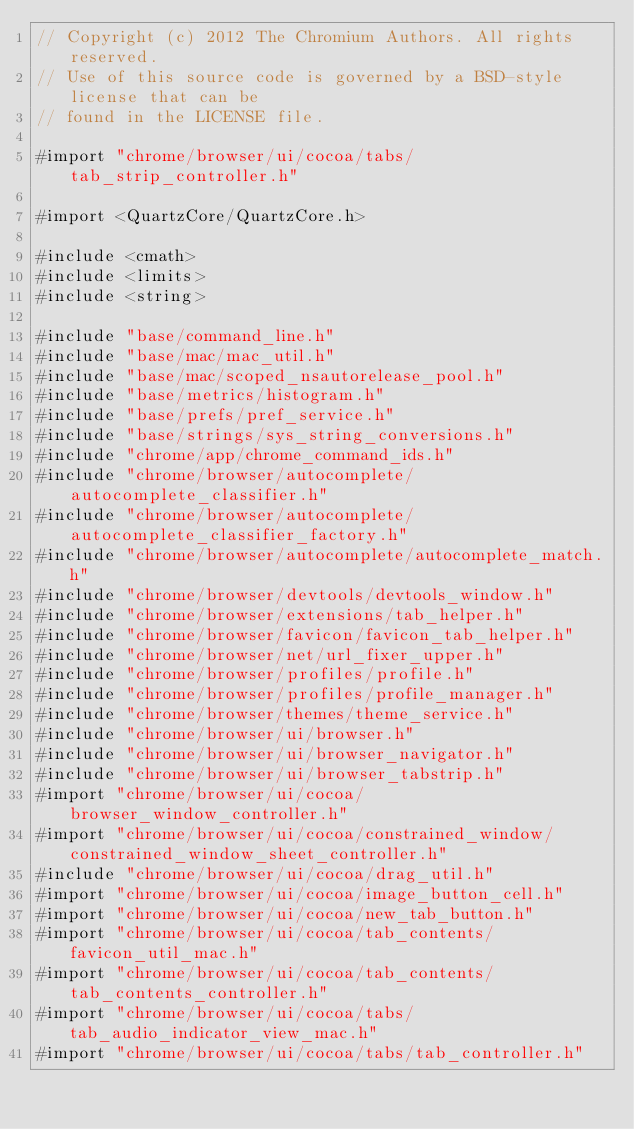Convert code to text. <code><loc_0><loc_0><loc_500><loc_500><_ObjectiveC_>// Copyright (c) 2012 The Chromium Authors. All rights reserved.
// Use of this source code is governed by a BSD-style license that can be
// found in the LICENSE file.

#import "chrome/browser/ui/cocoa/tabs/tab_strip_controller.h"

#import <QuartzCore/QuartzCore.h>

#include <cmath>
#include <limits>
#include <string>

#include "base/command_line.h"
#include "base/mac/mac_util.h"
#include "base/mac/scoped_nsautorelease_pool.h"
#include "base/metrics/histogram.h"
#include "base/prefs/pref_service.h"
#include "base/strings/sys_string_conversions.h"
#include "chrome/app/chrome_command_ids.h"
#include "chrome/browser/autocomplete/autocomplete_classifier.h"
#include "chrome/browser/autocomplete/autocomplete_classifier_factory.h"
#include "chrome/browser/autocomplete/autocomplete_match.h"
#include "chrome/browser/devtools/devtools_window.h"
#include "chrome/browser/extensions/tab_helper.h"
#include "chrome/browser/favicon/favicon_tab_helper.h"
#include "chrome/browser/net/url_fixer_upper.h"
#include "chrome/browser/profiles/profile.h"
#include "chrome/browser/profiles/profile_manager.h"
#include "chrome/browser/themes/theme_service.h"
#include "chrome/browser/ui/browser.h"
#include "chrome/browser/ui/browser_navigator.h"
#include "chrome/browser/ui/browser_tabstrip.h"
#import "chrome/browser/ui/cocoa/browser_window_controller.h"
#import "chrome/browser/ui/cocoa/constrained_window/constrained_window_sheet_controller.h"
#include "chrome/browser/ui/cocoa/drag_util.h"
#import "chrome/browser/ui/cocoa/image_button_cell.h"
#import "chrome/browser/ui/cocoa/new_tab_button.h"
#import "chrome/browser/ui/cocoa/tab_contents/favicon_util_mac.h"
#import "chrome/browser/ui/cocoa/tab_contents/tab_contents_controller.h"
#import "chrome/browser/ui/cocoa/tabs/tab_audio_indicator_view_mac.h"
#import "chrome/browser/ui/cocoa/tabs/tab_controller.h"</code> 